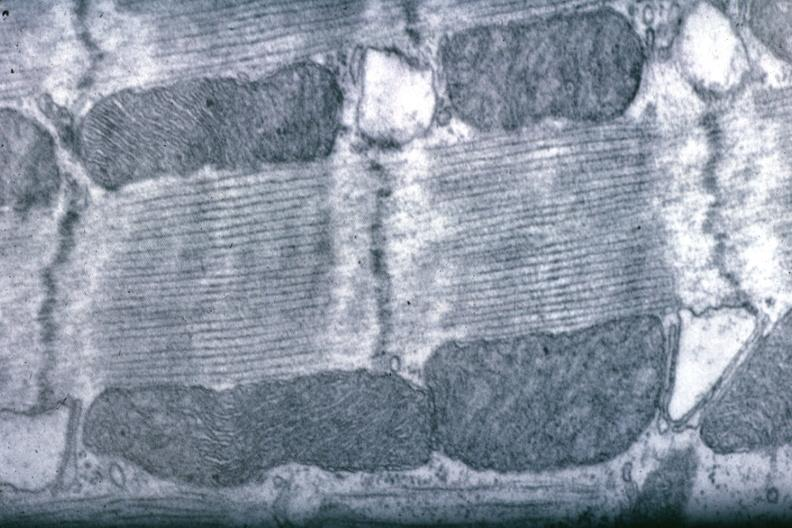what does this image show?
Answer the question using a single word or phrase. Good for banding pattern mitochondria 